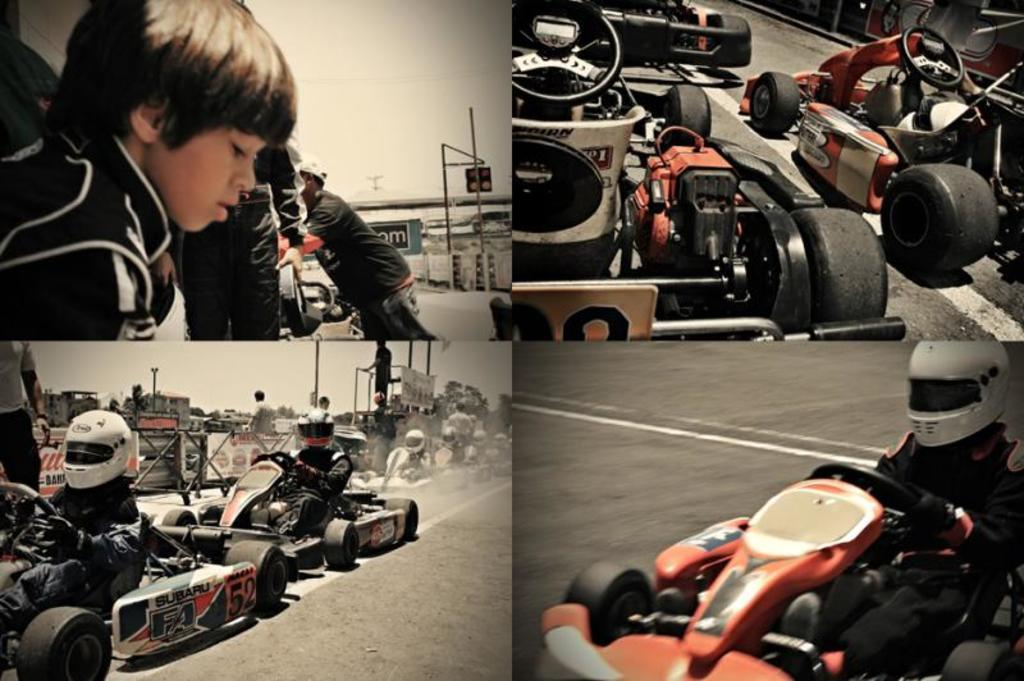What type of artwork is depicted in the image? The image is a collage. What is the main subject of the collage? The main subject of the collage is racing cars. What are the persons in the collage doing? The persons in the collage are sitting on the racing cars. Can you see a ring on the finger of the person sitting on the racing car in the image? There is no ring visible on the finger of the person sitting on the racing car in the image. What type of smile can be seen on the face of the person sitting on the racing car in the image? There is no smile visible on the face of the person sitting on the racing car in the image. 